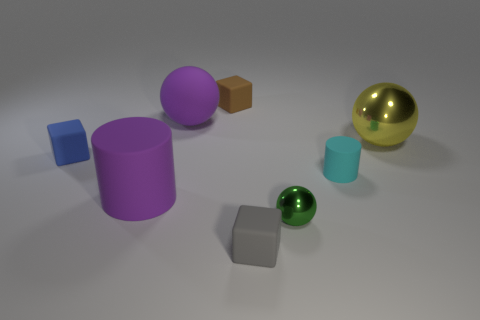If we consider these objects as part of a cityscape, which ones could represent buildings and which could symbolize parks or natural elements? In a metaphorical cityscape, the cubes and cylinders might represent buildings due to their geometric and block-like shapes, with the cubes as skyscrapers and cylinders as round-tower buildings. The spheres, with their smooth surfaces and green and gold colors, could symbolize parks or natural elements, like trees or the sun. 